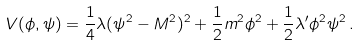<formula> <loc_0><loc_0><loc_500><loc_500>V ( \phi , \psi ) = \frac { 1 } { 4 } \lambda ( \psi ^ { 2 } - M ^ { 2 } ) ^ { 2 } + \frac { 1 } { 2 } m ^ { 2 } \phi ^ { 2 } + \frac { 1 } { 2 } \lambda ^ { \prime } \phi ^ { 2 } \psi ^ { 2 } \, .</formula> 